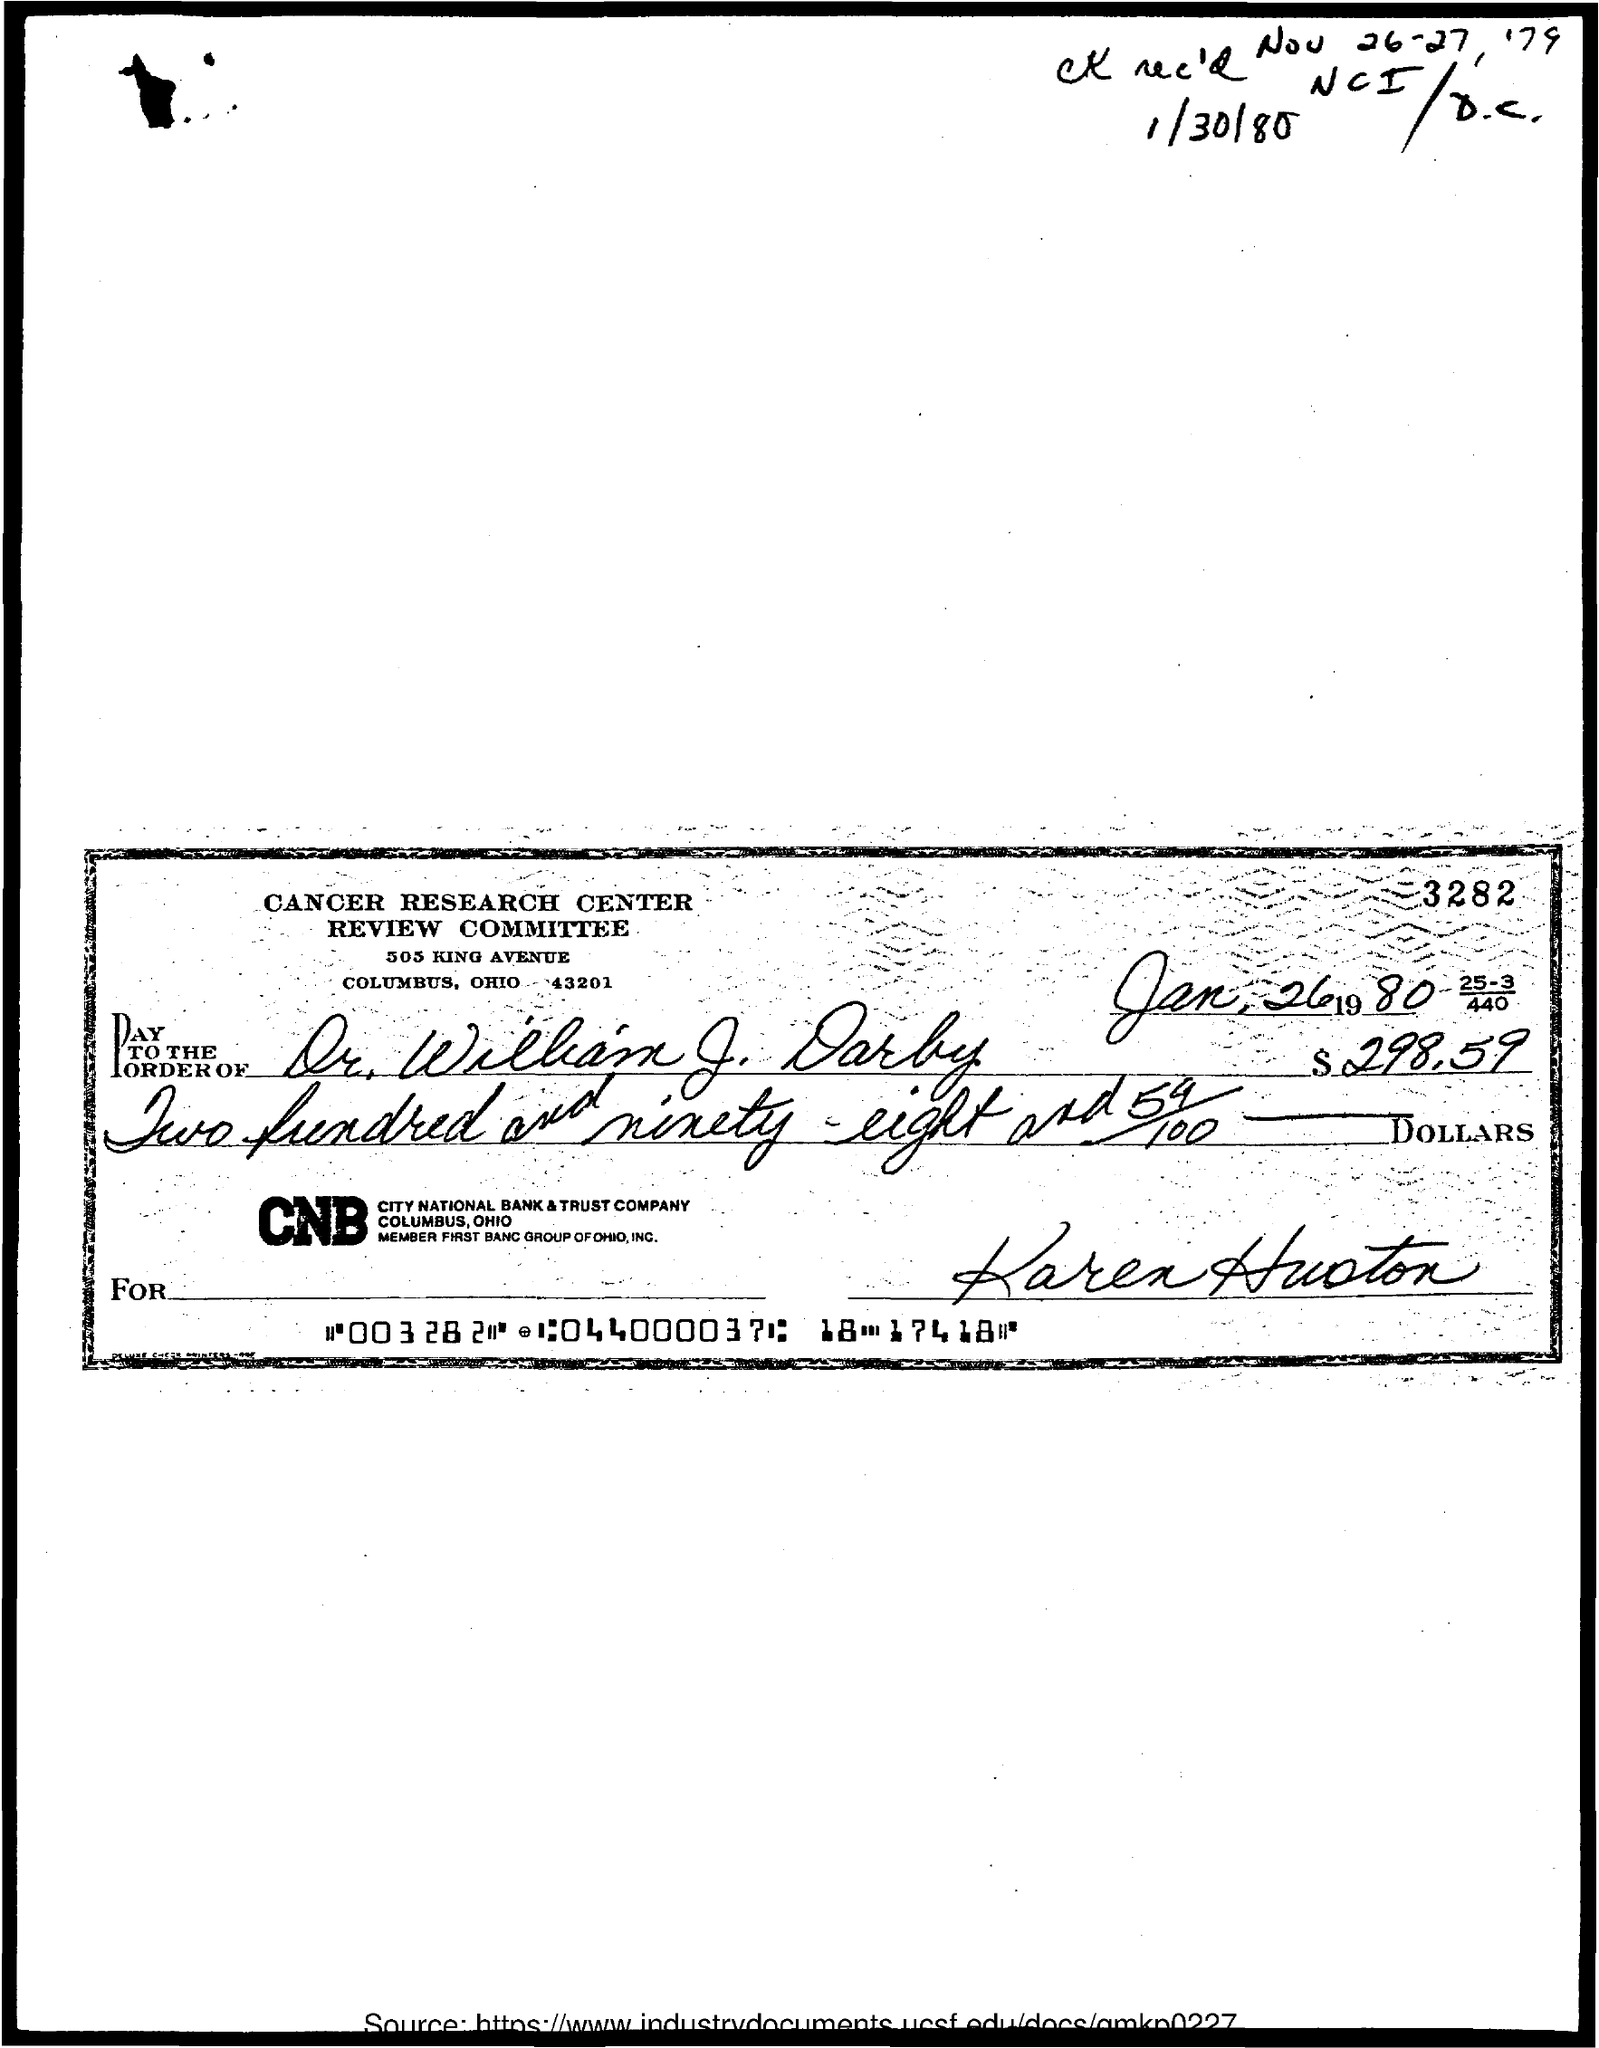What is the issued date of this check?
Offer a terse response. Jan, 26 1980. What is the payee name mentioned in the check?
Keep it short and to the point. Dr. William J. Darby. What is the amount mentioned in the check?
Offer a very short reply. $298.59. 